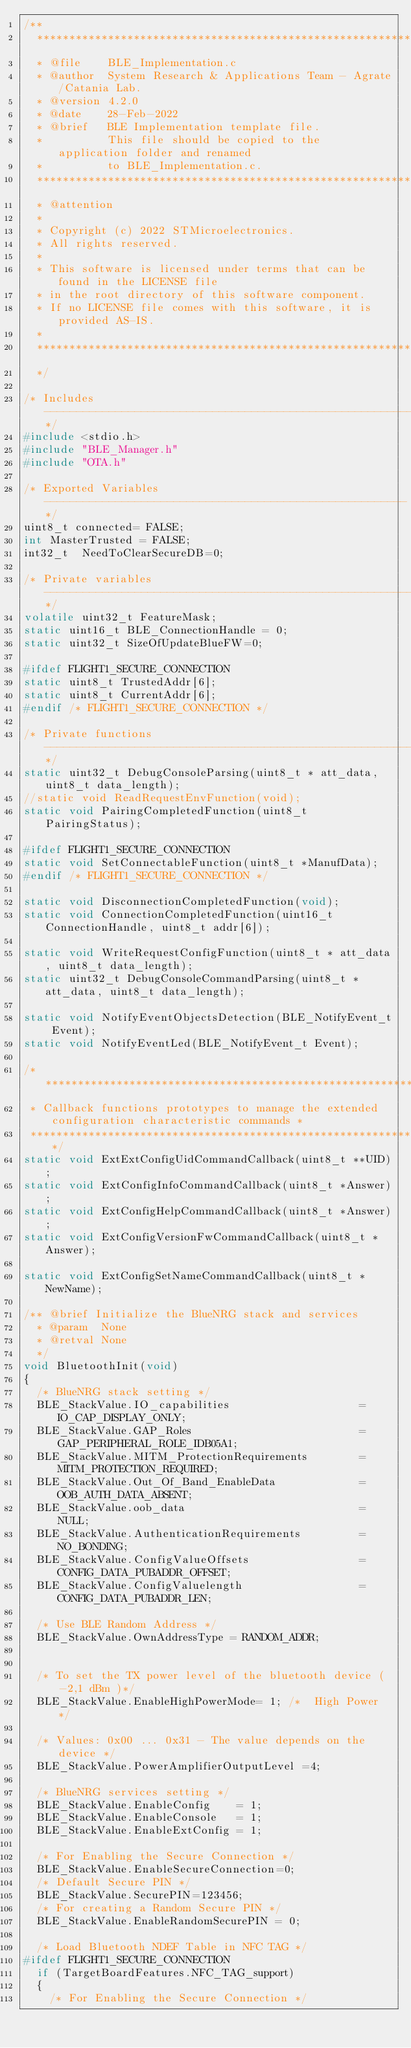<code> <loc_0><loc_0><loc_500><loc_500><_C_>/**
  ******************************************************************************
  * @file    BLE_Implementation.c
  * @author  System Research & Applications Team - Agrate/Catania Lab.
  * @version 4.2.0
  * @date    28-Feb-2022
  * @brief   BLE Implementation template file.
  *          This file should be copied to the application folder and renamed
  *          to BLE_Implementation.c.
  ******************************************************************************
  * @attention
  *
  * Copyright (c) 2022 STMicroelectronics.
  * All rights reserved.
  *
  * This software is licensed under terms that can be found in the LICENSE file
  * in the root directory of this software component.
  * If no LICENSE file comes with this software, it is provided AS-IS.
  *
  ******************************************************************************
  */

/* Includes ------------------------------------------------------------------*/
#include <stdio.h>
#include "BLE_Manager.h"
#include "OTA.h"

/* Exported Variables --------------------------------------------------------*/
uint8_t connected= FALSE;
int MasterTrusted = FALSE;
int32_t  NeedToClearSecureDB=0;

/* Private variables ------------------------------------------------------------*/
volatile uint32_t FeatureMask;
static uint16_t BLE_ConnectionHandle = 0;
static uint32_t SizeOfUpdateBlueFW=0;

#ifdef FLIGHT1_SECURE_CONNECTION
static uint8_t TrustedAddr[6];
static uint8_t CurrentAddr[6];
#endif /* FLIGHT1_SECURE_CONNECTION */
      
/* Private functions ---------------------------------------------------------*/
static uint32_t DebugConsoleParsing(uint8_t * att_data, uint8_t data_length);
//static void ReadRequestEnvFunction(void);
static void PairingCompletedFunction(uint8_t PairingStatus);

#ifdef FLIGHT1_SECURE_CONNECTION
static void SetConnectableFunction(uint8_t *ManufData);
#endif /* FLIGHT1_SECURE_CONNECTION */

static void DisconnectionCompletedFunction(void);
static void ConnectionCompletedFunction(uint16_t ConnectionHandle, uint8_t addr[6]);

static void WriteRequestConfigFunction(uint8_t * att_data, uint8_t data_length);
static uint32_t DebugConsoleCommandParsing(uint8_t * att_data, uint8_t data_length);

static void NotifyEventObjectsDetection(BLE_NotifyEvent_t Event);
static void NotifyEventLed(BLE_NotifyEvent_t Event);

/**********************************************************************************************
 * Callback functions prototypes to manage the extended configuration characteristic commands *
 **********************************************************************************************/
static void ExtExtConfigUidCommandCallback(uint8_t **UID);
static void ExtConfigInfoCommandCallback(uint8_t *Answer);
static void ExtConfigHelpCommandCallback(uint8_t *Answer);
static void ExtConfigVersionFwCommandCallback(uint8_t *Answer);

static void ExtConfigSetNameCommandCallback(uint8_t *NewName);

/** @brief Initialize the BlueNRG stack and services
  * @param  None
  * @retval None
  */
void BluetoothInit(void)
{
  /* BlueNRG stack setting */
  BLE_StackValue.IO_capabilities                    = IO_CAP_DISPLAY_ONLY;
  BLE_StackValue.GAP_Roles                          = GAP_PERIPHERAL_ROLE_IDB05A1;
  BLE_StackValue.MITM_ProtectionRequirements        = MITM_PROTECTION_REQUIRED;
  BLE_StackValue.Out_Of_Band_EnableData             = OOB_AUTH_DATA_ABSENT;
  BLE_StackValue.oob_data                           = NULL;
  BLE_StackValue.AuthenticationRequirements         = NO_BONDING;
  BLE_StackValue.ConfigValueOffsets                 = CONFIG_DATA_PUBADDR_OFFSET;
  BLE_StackValue.ConfigValuelength                  = CONFIG_DATA_PUBADDR_LEN;
  
  /* Use BLE Random Address */
  BLE_StackValue.OwnAddressType = RANDOM_ADDR;


  /* To set the TX power level of the bluetooth device ( -2,1 dBm )*/
  BLE_StackValue.EnableHighPowerMode= 1; /*  High Power */
  
  /* Values: 0x00 ... 0x31 - The value depends on the device */
  BLE_StackValue.PowerAmplifierOutputLevel =4;
  
  /* BlueNRG services setting */
  BLE_StackValue.EnableConfig    = 1;
  BLE_StackValue.EnableConsole   = 1;
  BLE_StackValue.EnableExtConfig = 1;
  
  /* For Enabling the Secure Connection */
  BLE_StackValue.EnableSecureConnection=0;
  /* Default Secure PIN */
  BLE_StackValue.SecurePIN=123456;
  /* For creating a Random Secure PIN */
  BLE_StackValue.EnableRandomSecurePIN = 0;
  
  /* Load Bluetooth NDEF Table in NFC TAG */
#ifdef FLIGHT1_SECURE_CONNECTION   
  if (TargetBoardFeatures.NFC_TAG_support)
  {
    /* For Enabling the Secure Connection */</code> 